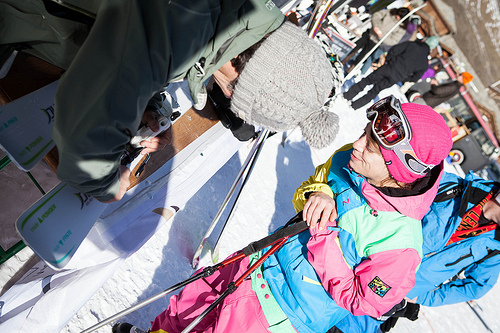<image>
Can you confirm if the hat is on the person? No. The hat is not positioned on the person. They may be near each other, but the hat is not supported by or resting on top of the person. Is there a woman in front of the man? Yes. The woman is positioned in front of the man, appearing closer to the camera viewpoint. 